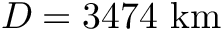<formula> <loc_0><loc_0><loc_500><loc_500>D = 3 4 7 4 { k m }</formula> 